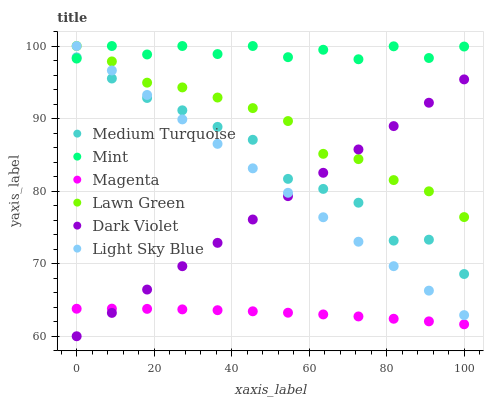Does Magenta have the minimum area under the curve?
Answer yes or no. Yes. Does Mint have the maximum area under the curve?
Answer yes or no. Yes. Does Dark Violet have the minimum area under the curve?
Answer yes or no. No. Does Dark Violet have the maximum area under the curve?
Answer yes or no. No. Is Dark Violet the smoothest?
Answer yes or no. Yes. Is Mint the roughest?
Answer yes or no. Yes. Is Light Sky Blue the smoothest?
Answer yes or no. No. Is Light Sky Blue the roughest?
Answer yes or no. No. Does Dark Violet have the lowest value?
Answer yes or no. Yes. Does Light Sky Blue have the lowest value?
Answer yes or no. No. Does Mint have the highest value?
Answer yes or no. Yes. Does Dark Violet have the highest value?
Answer yes or no. No. Is Magenta less than Mint?
Answer yes or no. Yes. Is Mint greater than Dark Violet?
Answer yes or no. Yes. Does Dark Violet intersect Light Sky Blue?
Answer yes or no. Yes. Is Dark Violet less than Light Sky Blue?
Answer yes or no. No. Is Dark Violet greater than Light Sky Blue?
Answer yes or no. No. Does Magenta intersect Mint?
Answer yes or no. No. 